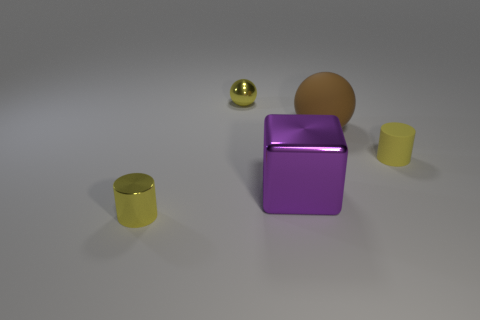Are there fewer purple shiny objects behind the small yellow rubber thing than tiny metal cylinders?
Provide a succinct answer. Yes. Do the purple metal thing and the rubber ball have the same size?
Ensure brevity in your answer.  Yes. What is the color of the small object that is made of the same material as the big brown sphere?
Your answer should be very brief. Yellow. Is the number of metallic cylinders that are to the right of the large metallic object less than the number of purple things on the right side of the yellow shiny sphere?
Provide a short and direct response. Yes. How many small spheres are the same color as the rubber cylinder?
Provide a succinct answer. 1. What material is the other tiny cylinder that is the same color as the small shiny cylinder?
Keep it short and to the point. Rubber. How many small yellow things are both on the left side of the brown object and to the right of the big rubber object?
Make the answer very short. 0. What material is the small ball right of the thing that is in front of the purple block made of?
Offer a very short reply. Metal. Are there any small yellow objects made of the same material as the brown ball?
Provide a succinct answer. Yes. What is the material of the ball that is the same size as the purple thing?
Your answer should be very brief. Rubber. 